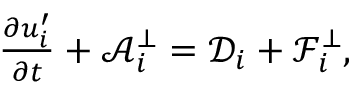<formula> <loc_0><loc_0><loc_500><loc_500>\begin{array} { r } { \frac { \partial { u } _ { i } ^ { \prime } } { \partial t } + \mathcal { A } _ { i } ^ { \bot } = \mathcal { D } _ { i } + \mathcal { F } _ { i } ^ { \bot } , } \end{array}</formula> 